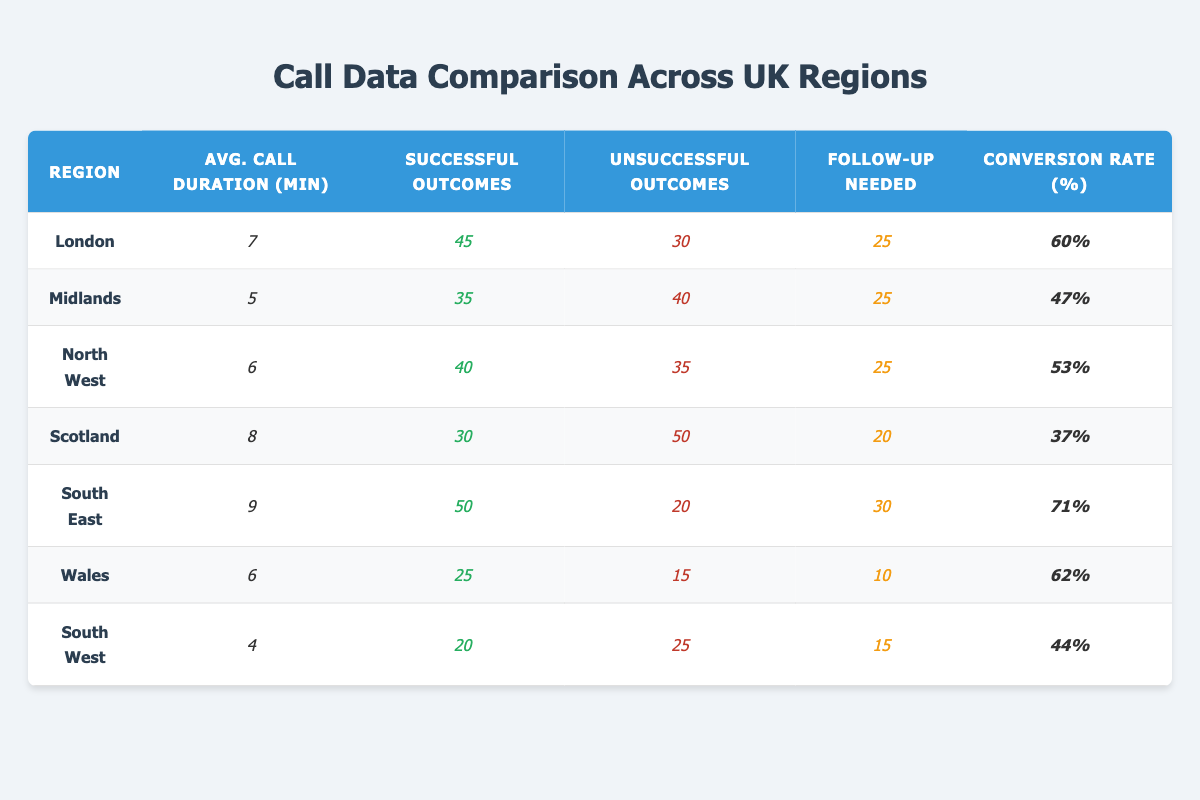What is the average call duration in Scotland? The table indicates that the average call duration for Scotland is explicitly listed as 8 minutes.
Answer: 8 minutes Which region has the highest conversion rate? Referring to the conversion rate percentages in the table, South East shows the highest conversion rate at 71%.
Answer: South East What is the total number of successful outcomes in Wales and South West combined? In Wales, the successful outcomes are 25, and in South West, they are 20. Thus, the total successful outcomes combined is 25 + 20 = 45.
Answer: 45 Is the average call duration in the Midlands less than that in the North West? The average call duration for Midlands is 5 minutes, and for North West, it is 6 minutes. Since 5 is less than 6, the statement holds true.
Answer: Yes How many follow-ups were needed in the South East and Scotland together? The number of follow-ups for South East is 30, and for Scotland, it is 20. Adding these gives 30 + 20 = 50.
Answer: 50 What is the average conversion rate of the regions excluding London and Scotland? The conversion rates for the remaining regions are Midlands (47%), North West (53%), South East (71%), Wales (62%), and South West (44%). The sum is 47 + 53 + 71 + 62 + 44 = 277. Since there are 5 regions, the average conversion rate is 277 / 5 = 55.4%.
Answer: 55.4% How does the unsuccessful outcome rate in the North West compare to that in Wales? In North West, unsuccessful outcomes are 35, and in Wales, they are 15. Since 35 is greater than 15, North West has a higher rate of unsuccessful outcomes compared to Wales.
Answer: North West Which region has the lowest average call duration and what is it? Looking at the average call durations, South West has the lowest at 4 minutes.
Answer: 4 minutes Calculate the difference in successful outcomes between the South East and Scotland. The successful outcomes for South East are 50, and for Scotland, they are 30. The difference is 50 - 30 = 20.
Answer: 20 Is the total number of follow-ups in London higher than the average number of follow-ups across all regions? Summing up all follow-ups gives 25 (London) + 25 (Midlands) + 25 (North West) + 20 (Scotland) + 30 (South East) + 10 (Wales) + 15 (South West) = 150. The average number of follow-ups is 150 / 7 = 21.43. Since 25 is greater than 21.43, the answer is yes.
Answer: Yes 